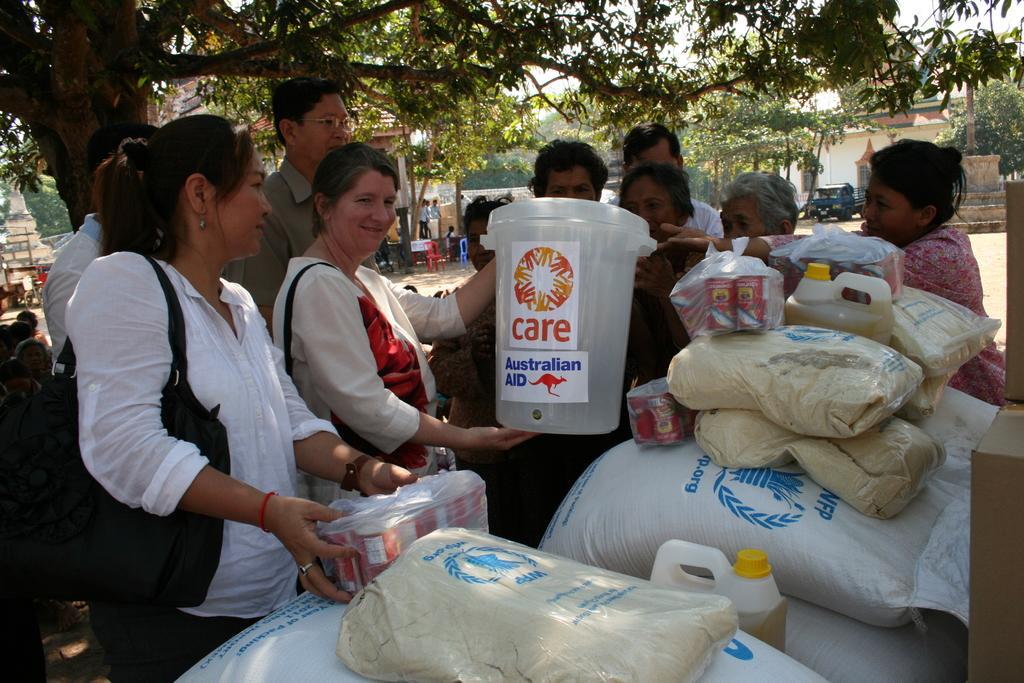Describe this image in one or two sentences. In the image we can see there are many people standing, wearing clothes and some of them are carrying a handbag. Here we can see a container, plastic gunny bags and there are objects wrapper in the cover. Here we can see trees, buildings, chairs and the sky. 